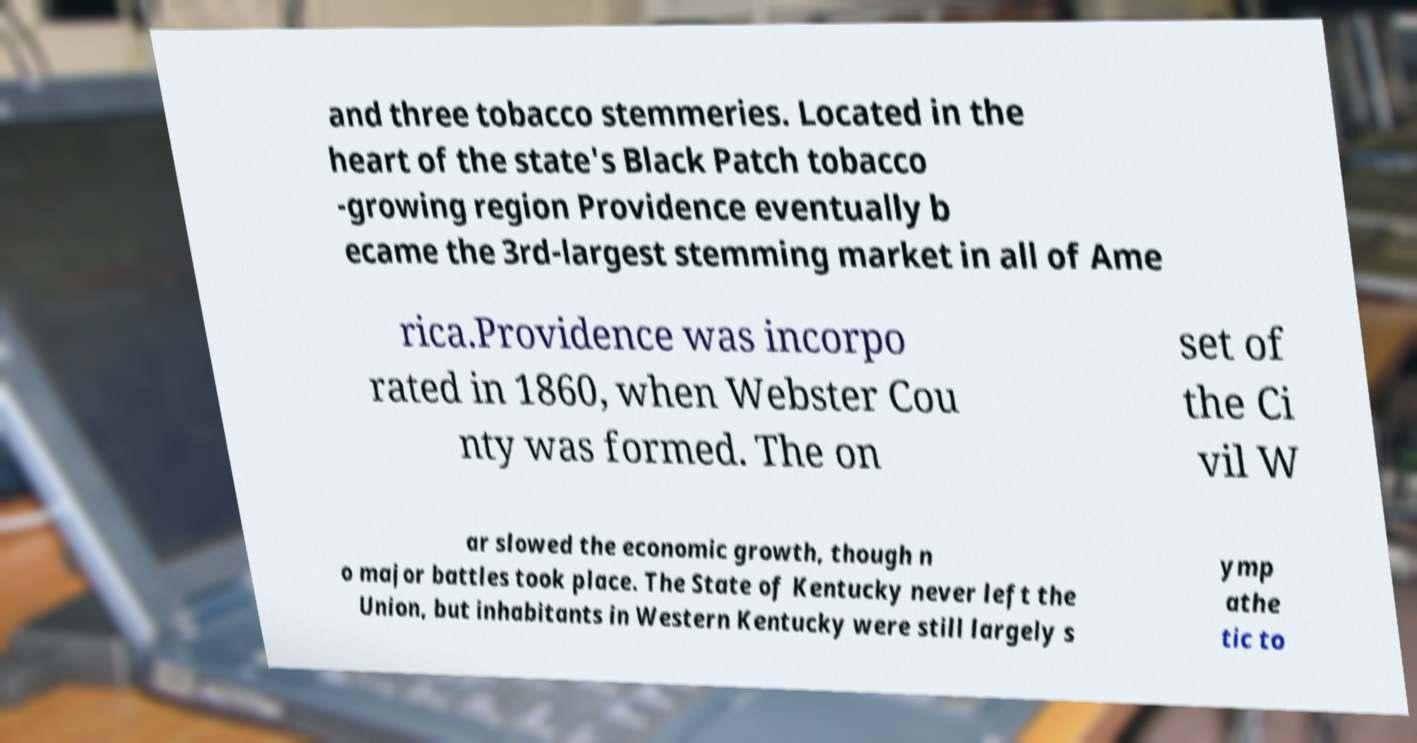There's text embedded in this image that I need extracted. Can you transcribe it verbatim? and three tobacco stemmeries. Located in the heart of the state's Black Patch tobacco -growing region Providence eventually b ecame the 3rd-largest stemming market in all of Ame rica.Providence was incorpo rated in 1860, when Webster Cou nty was formed. The on set of the Ci vil W ar slowed the economic growth, though n o major battles took place. The State of Kentucky never left the Union, but inhabitants in Western Kentucky were still largely s ymp athe tic to 